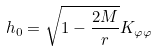<formula> <loc_0><loc_0><loc_500><loc_500>h _ { 0 } = \sqrt { 1 - \frac { 2 M } r } K _ { \varphi \varphi }</formula> 